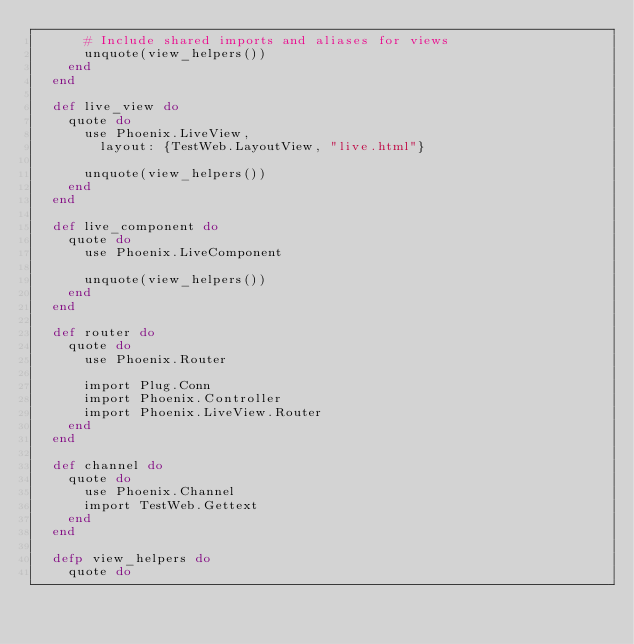Convert code to text. <code><loc_0><loc_0><loc_500><loc_500><_Elixir_>      # Include shared imports and aliases for views
      unquote(view_helpers())
    end
  end

  def live_view do
    quote do
      use Phoenix.LiveView,
        layout: {TestWeb.LayoutView, "live.html"}

      unquote(view_helpers())
    end
  end

  def live_component do
    quote do
      use Phoenix.LiveComponent

      unquote(view_helpers())
    end
  end

  def router do
    quote do
      use Phoenix.Router

      import Plug.Conn
      import Phoenix.Controller
      import Phoenix.LiveView.Router
    end
  end

  def channel do
    quote do
      use Phoenix.Channel
      import TestWeb.Gettext
    end
  end

  defp view_helpers do
    quote do</code> 